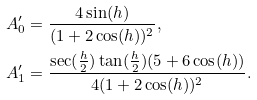Convert formula to latex. <formula><loc_0><loc_0><loc_500><loc_500>A ^ { \prime } _ { 0 } & = \frac { 4 \sin ( h ) } { ( 1 + 2 \cos ( h ) ) ^ { 2 } } , \\ A ^ { \prime } _ { 1 } & = \frac { \sec ( \frac { h } { 2 } ) \tan ( \frac { h } { 2 } ) ( 5 + 6 \cos ( h ) ) } { 4 ( 1 + 2 \cos ( h ) ) ^ { 2 } } .</formula> 